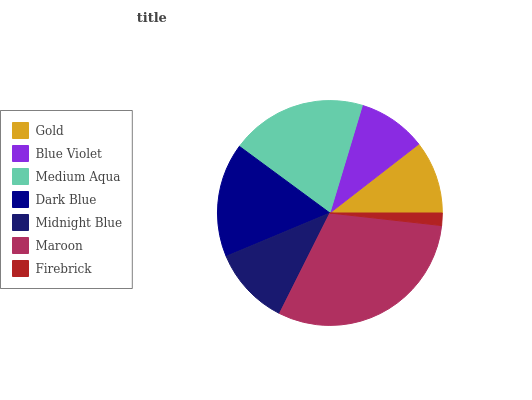Is Firebrick the minimum?
Answer yes or no. Yes. Is Maroon the maximum?
Answer yes or no. Yes. Is Blue Violet the minimum?
Answer yes or no. No. Is Blue Violet the maximum?
Answer yes or no. No. Is Gold greater than Blue Violet?
Answer yes or no. Yes. Is Blue Violet less than Gold?
Answer yes or no. Yes. Is Blue Violet greater than Gold?
Answer yes or no. No. Is Gold less than Blue Violet?
Answer yes or no. No. Is Midnight Blue the high median?
Answer yes or no. Yes. Is Midnight Blue the low median?
Answer yes or no. Yes. Is Dark Blue the high median?
Answer yes or no. No. Is Dark Blue the low median?
Answer yes or no. No. 